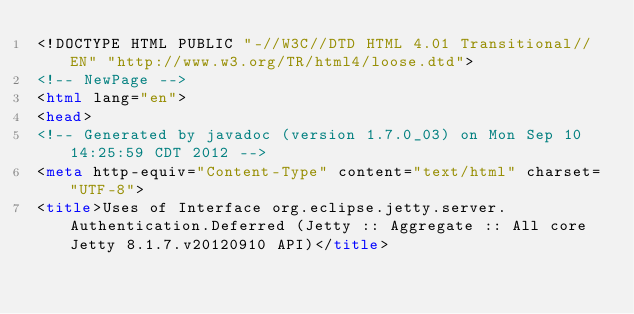Convert code to text. <code><loc_0><loc_0><loc_500><loc_500><_HTML_><!DOCTYPE HTML PUBLIC "-//W3C//DTD HTML 4.01 Transitional//EN" "http://www.w3.org/TR/html4/loose.dtd">
<!-- NewPage -->
<html lang="en">
<head>
<!-- Generated by javadoc (version 1.7.0_03) on Mon Sep 10 14:25:59 CDT 2012 -->
<meta http-equiv="Content-Type" content="text/html" charset="UTF-8">
<title>Uses of Interface org.eclipse.jetty.server.Authentication.Deferred (Jetty :: Aggregate :: All core Jetty 8.1.7.v20120910 API)</title></code> 